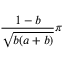Convert formula to latex. <formula><loc_0><loc_0><loc_500><loc_500>\frac { 1 - b } { \sqrt { b ( a + b ) } } \pi</formula> 